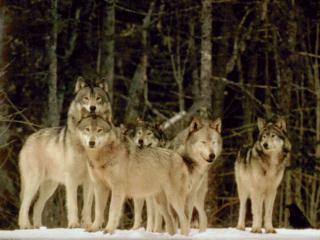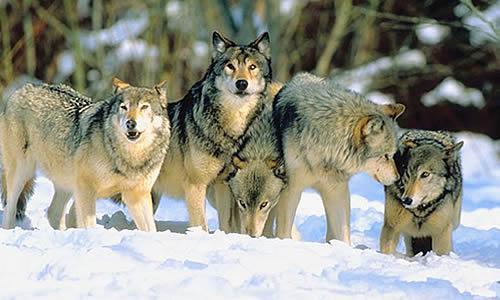The first image is the image on the left, the second image is the image on the right. For the images shown, is this caption "There are some wolves with white necks that have their heads titled up and are howling." true? Answer yes or no. No. The first image is the image on the left, the second image is the image on the right. Given the left and right images, does the statement "The image on the left contains at least five wolves that are howling." hold true? Answer yes or no. No. 